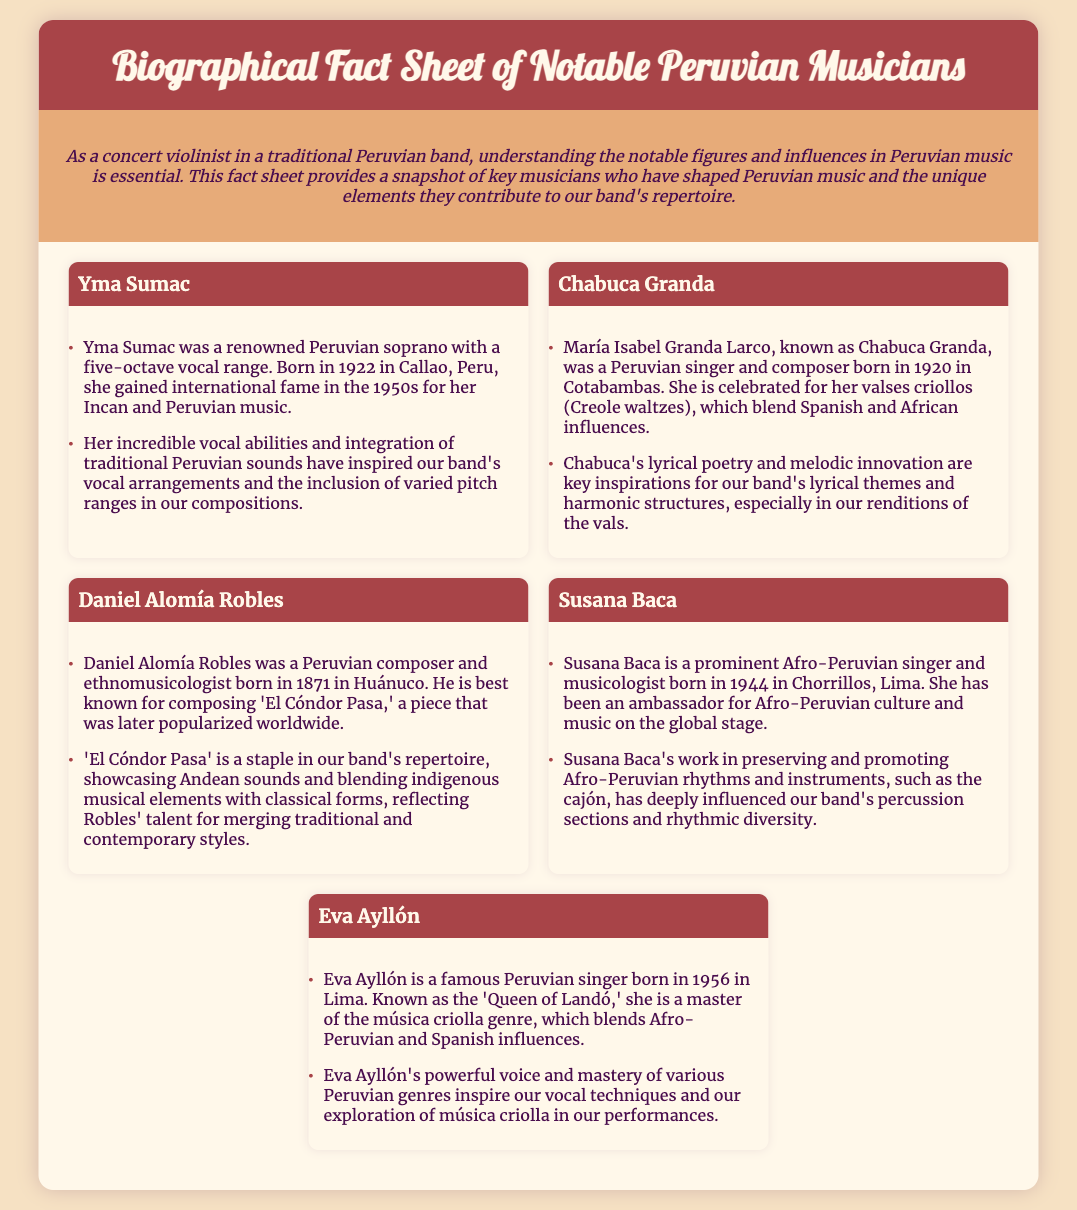What is the full name of Yma Sumac? Yma Sumac is the stage name of the renowned Peruvian soprano, not indicated in the fact sheet.
Answer: Not provided Which city was Chabuca Granda born in? The document states that she was born in Cotabambas.
Answer: Cotabambas What significant song did Daniel Alomía Robles compose? The document highlights 'El Cóndor Pasa' as his most famous work.
Answer: El Cóndor Pasa What genre is Eva Ayllón known for? The fact sheet describes her as the 'Queen of Landó' and a master of música criolla.
Answer: música criolla In what year was Susana Baca born? The document provides the year she was born as 1944.
Answer: 1944 How many octaves does Yma Sumac's vocal range encompass? The document mentions her five-octave vocal range.
Answer: five Which instrument is notably associated with Afro-Peruvian music mentioned in relation to Susana Baca? The fact sheet specifically notes the cajón as a prominent instrument.
Answer: cajón What has Chabuca Granda's music contributed to the band's repertoire? The document states her lyrical poetry and melodic innovations inspire the band's themes and structures.
Answer: lyrical poetry and melodic innovation What is the primary influence of Daniel Alomía Robles's 'El Cóndor Pasa' on the band? The document references it as a staple showcasing Andean sounds in the band’s repertoire.
Answer: showcasing Andean sounds 